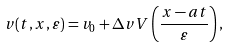<formula> <loc_0><loc_0><loc_500><loc_500>v ( t , x , \varepsilon ) = v _ { 0 } + \Delta v V \left ( \frac { x - a t } { \varepsilon } \right ) ,</formula> 